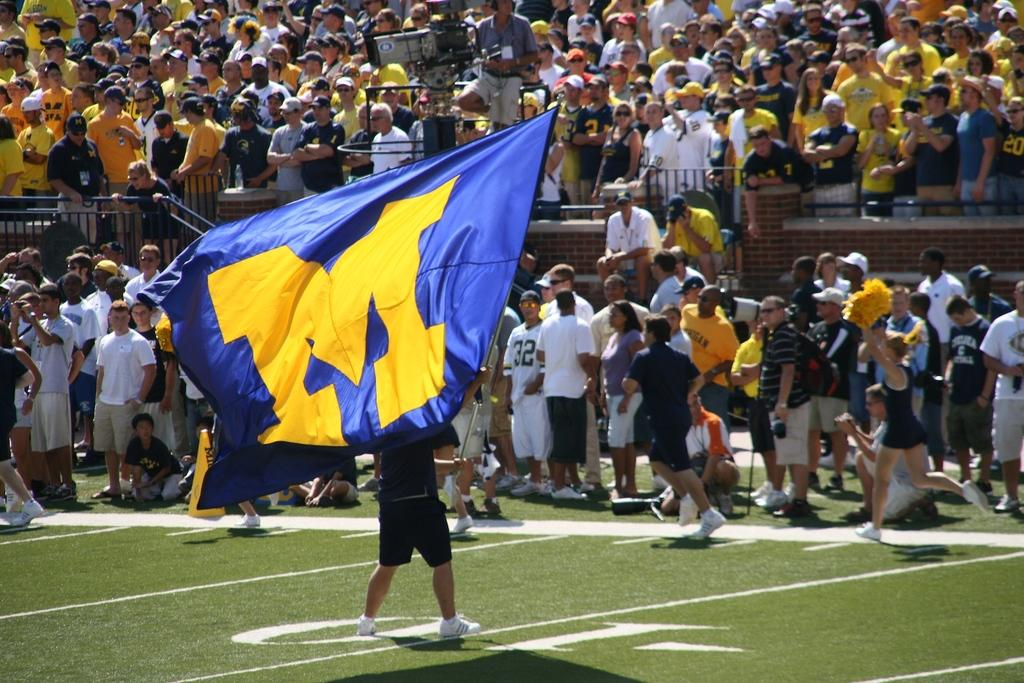<image>
Render a clear and concise summary of the photo. A supporter waves a huge blue flag with a yellow "M" on it iin front of crowds of supporters at a football game. 